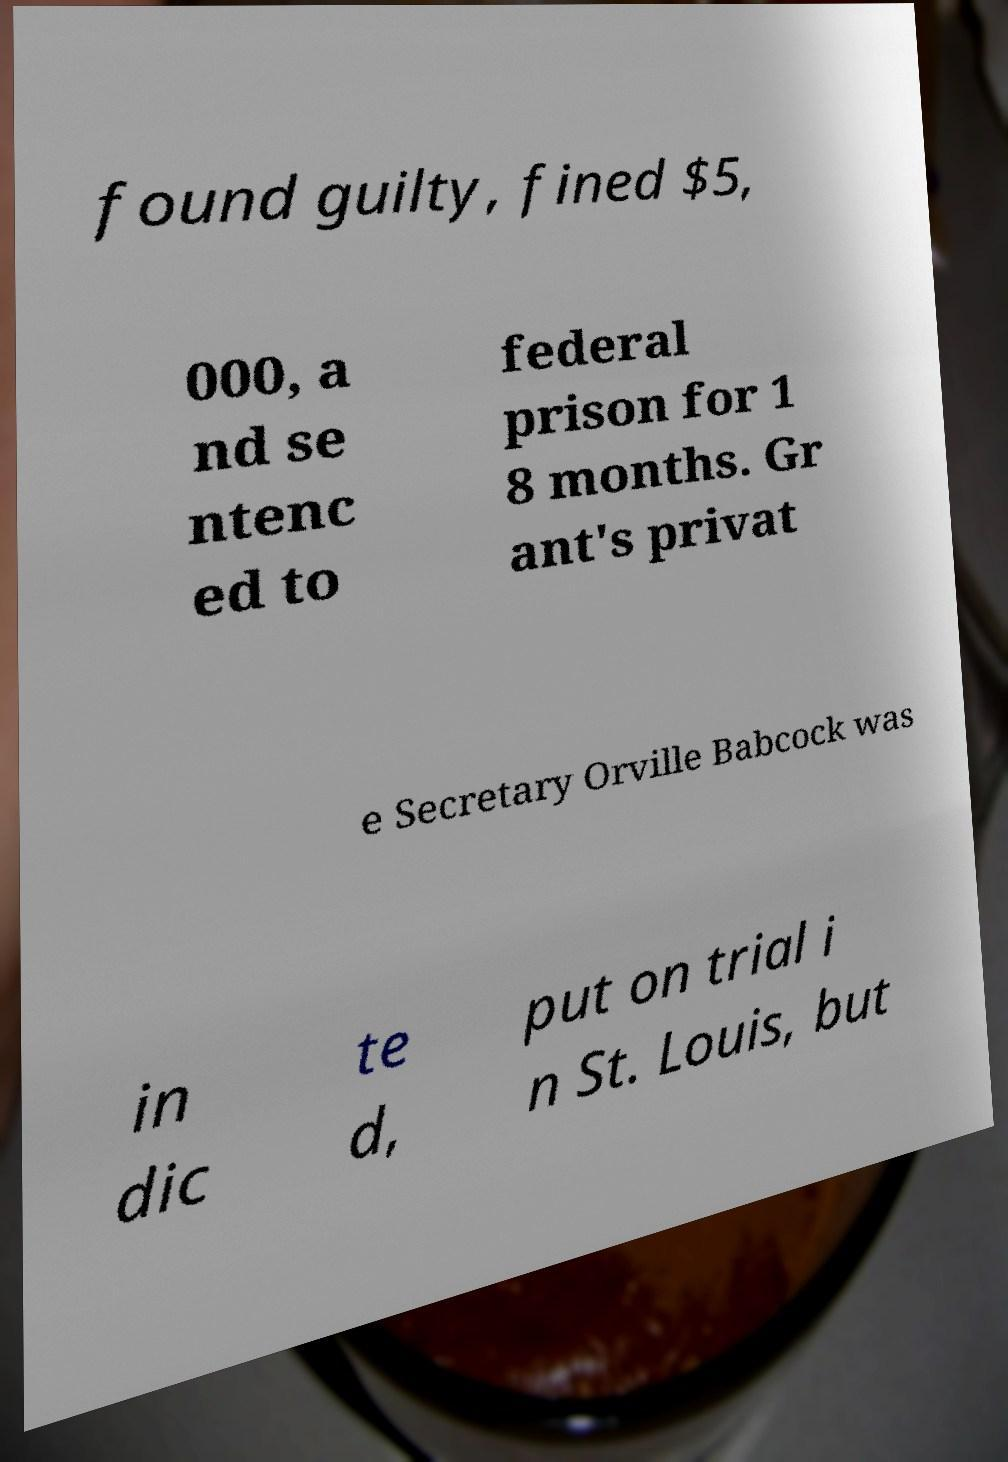For documentation purposes, I need the text within this image transcribed. Could you provide that? found guilty, fined $5, 000, a nd se ntenc ed to federal prison for 1 8 months. Gr ant's privat e Secretary Orville Babcock was in dic te d, put on trial i n St. Louis, but 